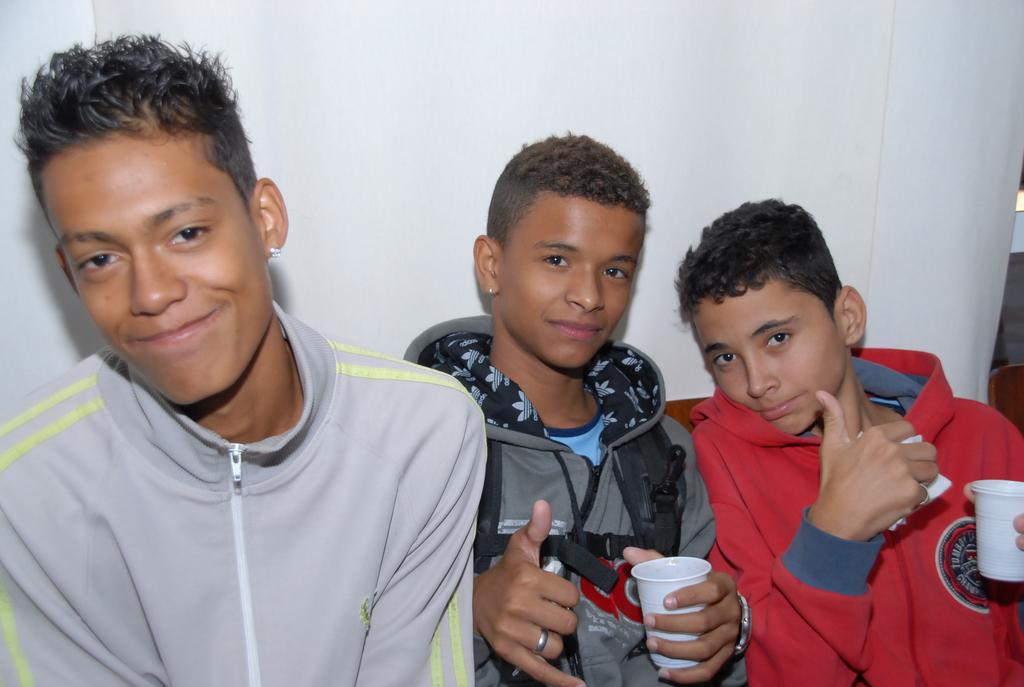How many boys are present in the image? There are three boys in the image. What are two of the boys holding in their hands? Two of the boys are holding cups in their hands. Can you describe something in the background of the image? There is a cloth visible in the background of the image. What can be seen on the right side of the image? There are objects on the right side of the image. What type of blade is being used by the laborer in the image? There is no laborer or blade present in the image. What type of fuel is being used by the boys in the image? There is no fuel present in the image; the boys are holding cups, which could contain a beverage. 